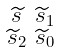Convert formula to latex. <formula><loc_0><loc_0><loc_500><loc_500>\begin{smallmatrix} \widetilde { s } & \widetilde { s } _ { 1 } \\ \widetilde { s } _ { 2 } & \widetilde { s } _ { 0 } \end{smallmatrix}</formula> 